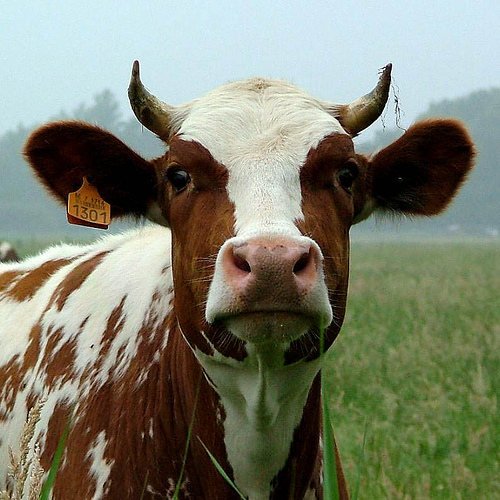Read and extract the text from this image. M 7 1714 1301 